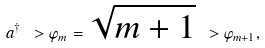Convert formula to latex. <formula><loc_0><loc_0><loc_500><loc_500>a ^ { \dagger } \ > \varphi _ { m } = \sqrt { m + 1 } \ > \varphi _ { m + 1 } ,</formula> 